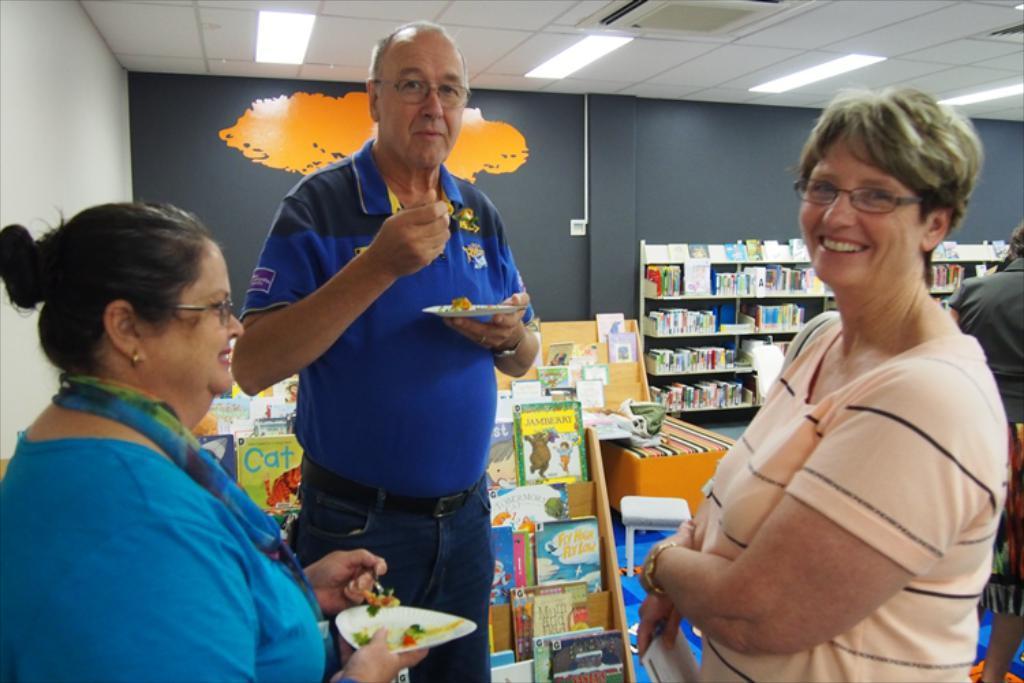Please provide a concise description of this image. In this image in the left an old man and a lady standing. They are having food. In front of them a lady is standing with a smiling face. She is holding something. In the background there are book racks, tables, stool, wall, painting. On the ceiling there are lights. There are few other people in the background. 